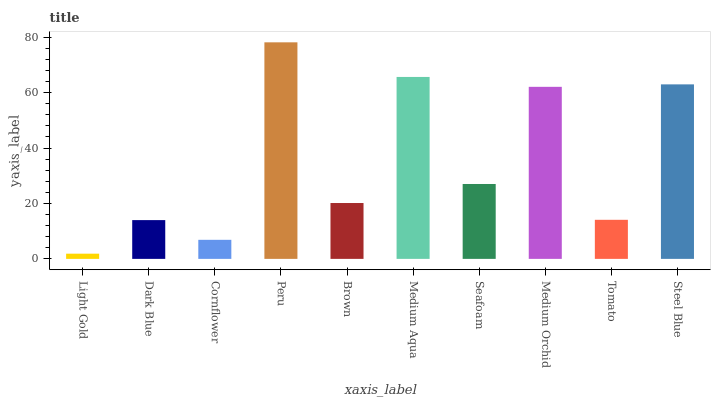Is Light Gold the minimum?
Answer yes or no. Yes. Is Peru the maximum?
Answer yes or no. Yes. Is Dark Blue the minimum?
Answer yes or no. No. Is Dark Blue the maximum?
Answer yes or no. No. Is Dark Blue greater than Light Gold?
Answer yes or no. Yes. Is Light Gold less than Dark Blue?
Answer yes or no. Yes. Is Light Gold greater than Dark Blue?
Answer yes or no. No. Is Dark Blue less than Light Gold?
Answer yes or no. No. Is Seafoam the high median?
Answer yes or no. Yes. Is Brown the low median?
Answer yes or no. Yes. Is Peru the high median?
Answer yes or no. No. Is Peru the low median?
Answer yes or no. No. 